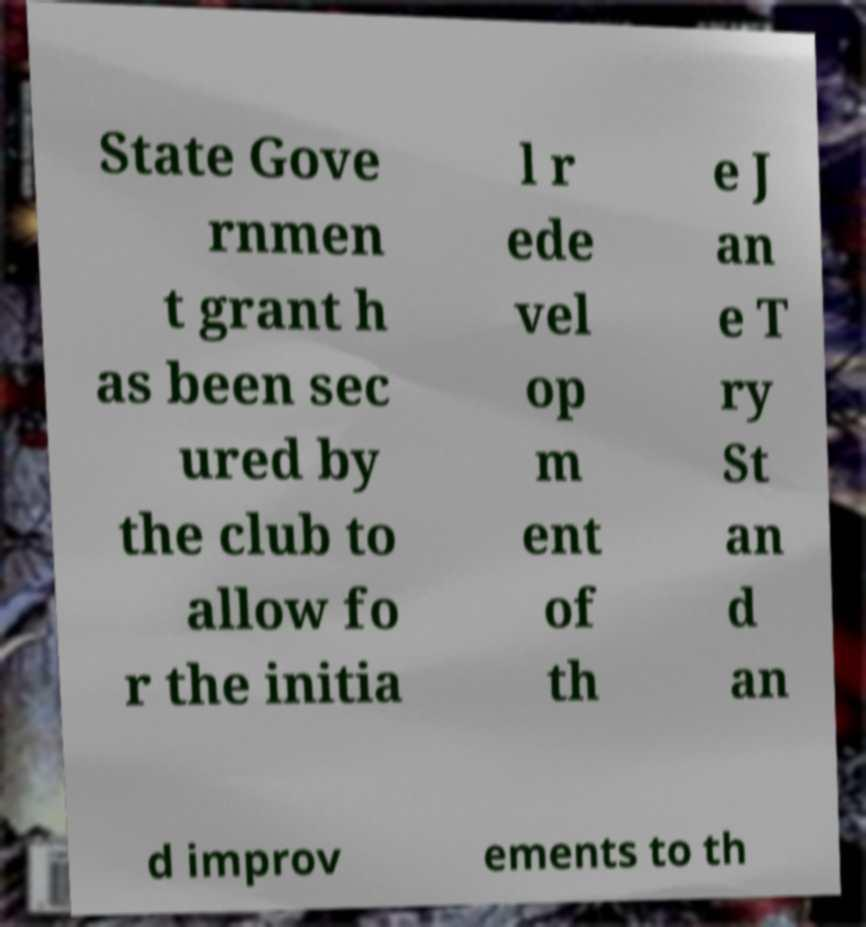There's text embedded in this image that I need extracted. Can you transcribe it verbatim? State Gove rnmen t grant h as been sec ured by the club to allow fo r the initia l r ede vel op m ent of th e J an e T ry St an d an d improv ements to th 